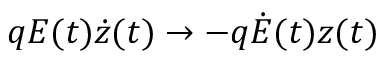Convert formula to latex. <formula><loc_0><loc_0><loc_500><loc_500>q E ( t ) \dot { z } ( t ) \rightarrow - q \dot { E } ( t ) z ( t )</formula> 